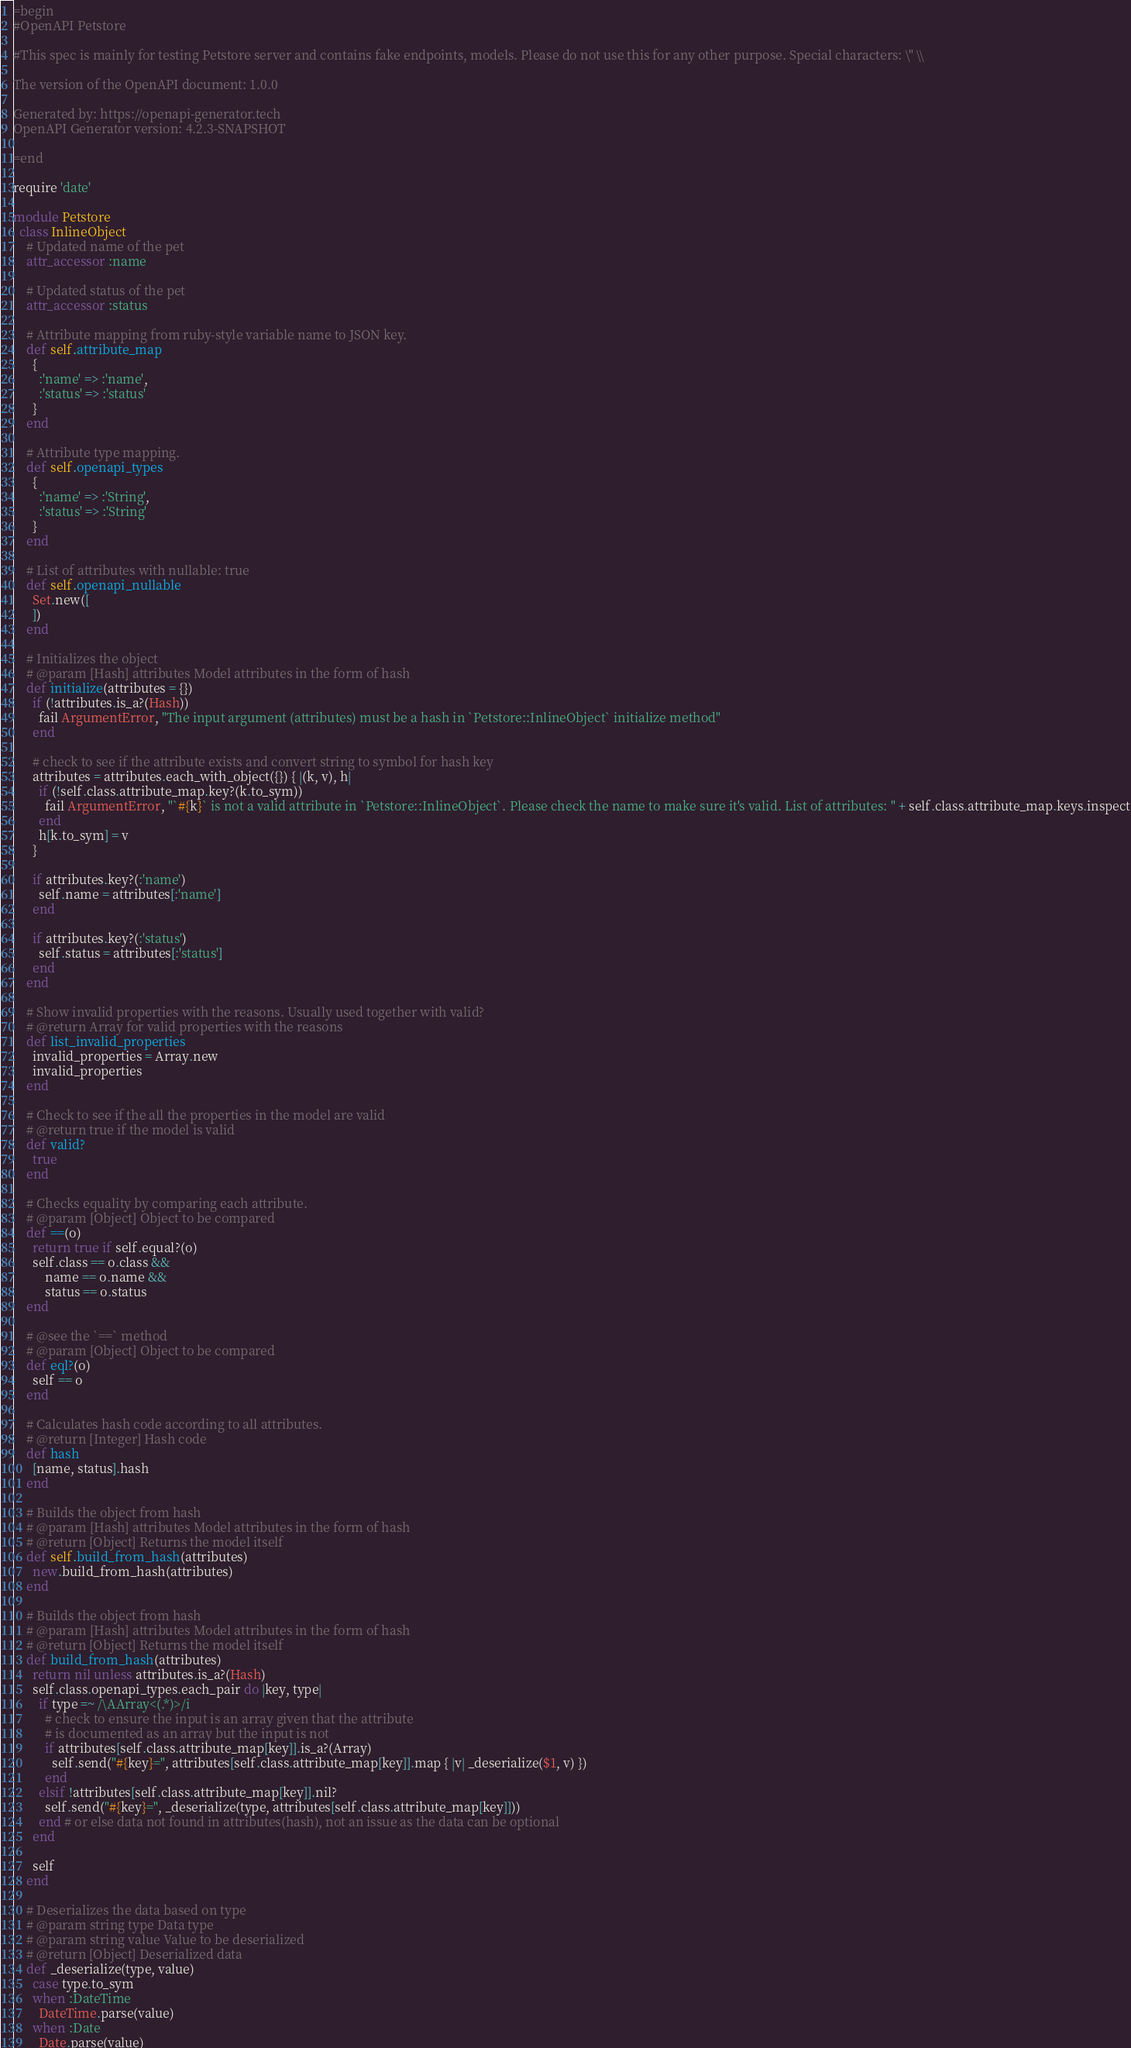Convert code to text. <code><loc_0><loc_0><loc_500><loc_500><_Ruby_>=begin
#OpenAPI Petstore

#This spec is mainly for testing Petstore server and contains fake endpoints, models. Please do not use this for any other purpose. Special characters: \" \\

The version of the OpenAPI document: 1.0.0

Generated by: https://openapi-generator.tech
OpenAPI Generator version: 4.2.3-SNAPSHOT

=end

require 'date'

module Petstore
  class InlineObject
    # Updated name of the pet
    attr_accessor :name

    # Updated status of the pet
    attr_accessor :status

    # Attribute mapping from ruby-style variable name to JSON key.
    def self.attribute_map
      {
        :'name' => :'name',
        :'status' => :'status'
      }
    end

    # Attribute type mapping.
    def self.openapi_types
      {
        :'name' => :'String',
        :'status' => :'String'
      }
    end

    # List of attributes with nullable: true
    def self.openapi_nullable
      Set.new([
      ])
    end

    # Initializes the object
    # @param [Hash] attributes Model attributes in the form of hash
    def initialize(attributes = {})
      if (!attributes.is_a?(Hash))
        fail ArgumentError, "The input argument (attributes) must be a hash in `Petstore::InlineObject` initialize method"
      end

      # check to see if the attribute exists and convert string to symbol for hash key
      attributes = attributes.each_with_object({}) { |(k, v), h|
        if (!self.class.attribute_map.key?(k.to_sym))
          fail ArgumentError, "`#{k}` is not a valid attribute in `Petstore::InlineObject`. Please check the name to make sure it's valid. List of attributes: " + self.class.attribute_map.keys.inspect
        end
        h[k.to_sym] = v
      }

      if attributes.key?(:'name')
        self.name = attributes[:'name']
      end

      if attributes.key?(:'status')
        self.status = attributes[:'status']
      end
    end

    # Show invalid properties with the reasons. Usually used together with valid?
    # @return Array for valid properties with the reasons
    def list_invalid_properties
      invalid_properties = Array.new
      invalid_properties
    end

    # Check to see if the all the properties in the model are valid
    # @return true if the model is valid
    def valid?
      true
    end

    # Checks equality by comparing each attribute.
    # @param [Object] Object to be compared
    def ==(o)
      return true if self.equal?(o)
      self.class == o.class &&
          name == o.name &&
          status == o.status
    end

    # @see the `==` method
    # @param [Object] Object to be compared
    def eql?(o)
      self == o
    end

    # Calculates hash code according to all attributes.
    # @return [Integer] Hash code
    def hash
      [name, status].hash
    end

    # Builds the object from hash
    # @param [Hash] attributes Model attributes in the form of hash
    # @return [Object] Returns the model itself
    def self.build_from_hash(attributes)
      new.build_from_hash(attributes)
    end

    # Builds the object from hash
    # @param [Hash] attributes Model attributes in the form of hash
    # @return [Object] Returns the model itself
    def build_from_hash(attributes)
      return nil unless attributes.is_a?(Hash)
      self.class.openapi_types.each_pair do |key, type|
        if type =~ /\AArray<(.*)>/i
          # check to ensure the input is an array given that the attribute
          # is documented as an array but the input is not
          if attributes[self.class.attribute_map[key]].is_a?(Array)
            self.send("#{key}=", attributes[self.class.attribute_map[key]].map { |v| _deserialize($1, v) })
          end
        elsif !attributes[self.class.attribute_map[key]].nil?
          self.send("#{key}=", _deserialize(type, attributes[self.class.attribute_map[key]]))
        end # or else data not found in attributes(hash), not an issue as the data can be optional
      end

      self
    end

    # Deserializes the data based on type
    # @param string type Data type
    # @param string value Value to be deserialized
    # @return [Object] Deserialized data
    def _deserialize(type, value)
      case type.to_sym
      when :DateTime
        DateTime.parse(value)
      when :Date
        Date.parse(value)</code> 